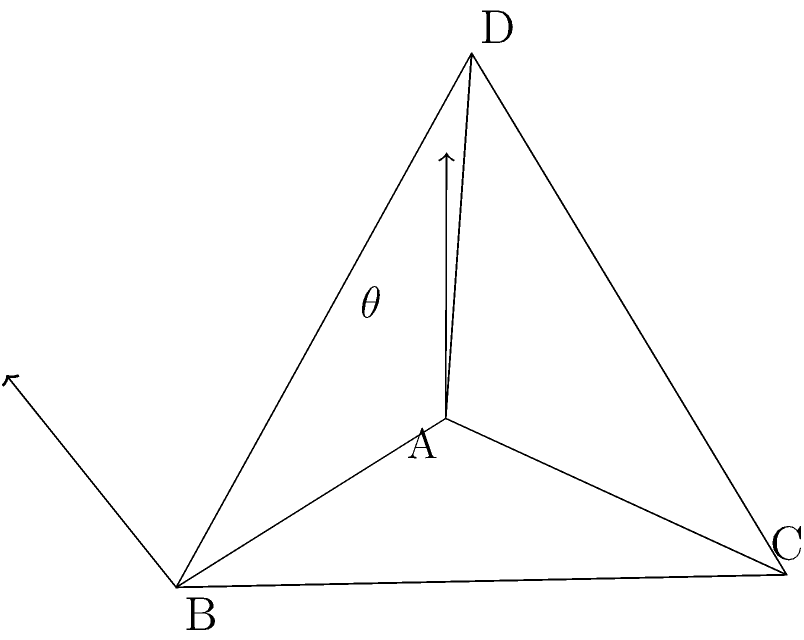In a magical tetrahedral crystal, two of its faces possess unique enchanted properties. The angle between the normal vectors of these faces is crucial for amplifying the crystal's power. Given a regular tetrahedron ABCD with side length 1, calculate the angle $\theta$ between the normal vectors of faces ABC and ABD. Let's approach this step-by-step:

1) In a regular tetrahedron, all faces are congruent equilateral triangles.

2) The angle between two face normals is supplementary to the dihedral angle between the faces. So, we need to find the dihedral angle first and then subtract it from 180°.

3) The dihedral angle $\phi$ of a regular tetrahedron can be calculated using the formula:

   $$\cos \phi = -\frac{1}{3}$$

4) Solving for $\phi$:

   $$\phi = \arccos(-\frac{1}{3}) \approx 109.47°$$

5) The angle $\theta$ between the normal vectors is:

   $$\theta = 180° - \phi = 180° - 109.47° = 70.53°$$

6) To express this in radians:

   $$\theta = \frac{70.53 \pi}{180} \approx 1.23 \text{ radians}$$

Therefore, the angle between the normal vectors of faces ABC and ABD is approximately 70.53° or 1.23 radians.
Answer: $70.53°$ or $1.23 \text{ radians}$ 